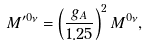<formula> <loc_0><loc_0><loc_500><loc_500>M ^ { \prime 0 \nu } = \left ( \frac { g _ { A } } { 1 . 2 5 } \right ) ^ { 2 } M ^ { 0 \nu } ,</formula> 